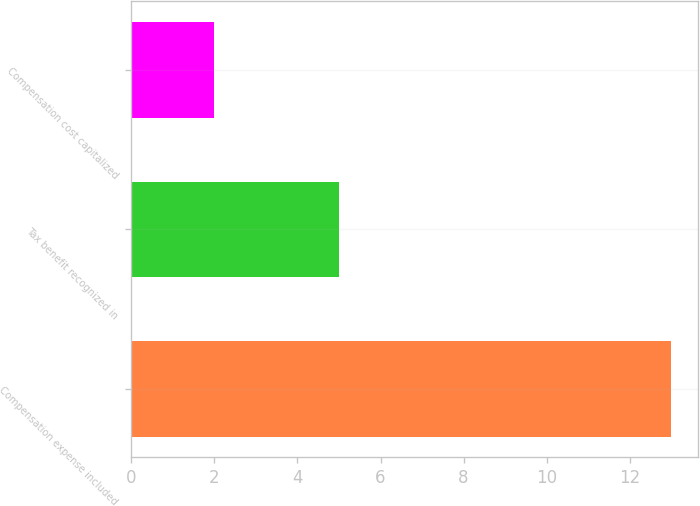<chart> <loc_0><loc_0><loc_500><loc_500><bar_chart><fcel>Compensation expense included<fcel>Tax benefit recognized in<fcel>Compensation cost capitalized<nl><fcel>13<fcel>5<fcel>2<nl></chart> 